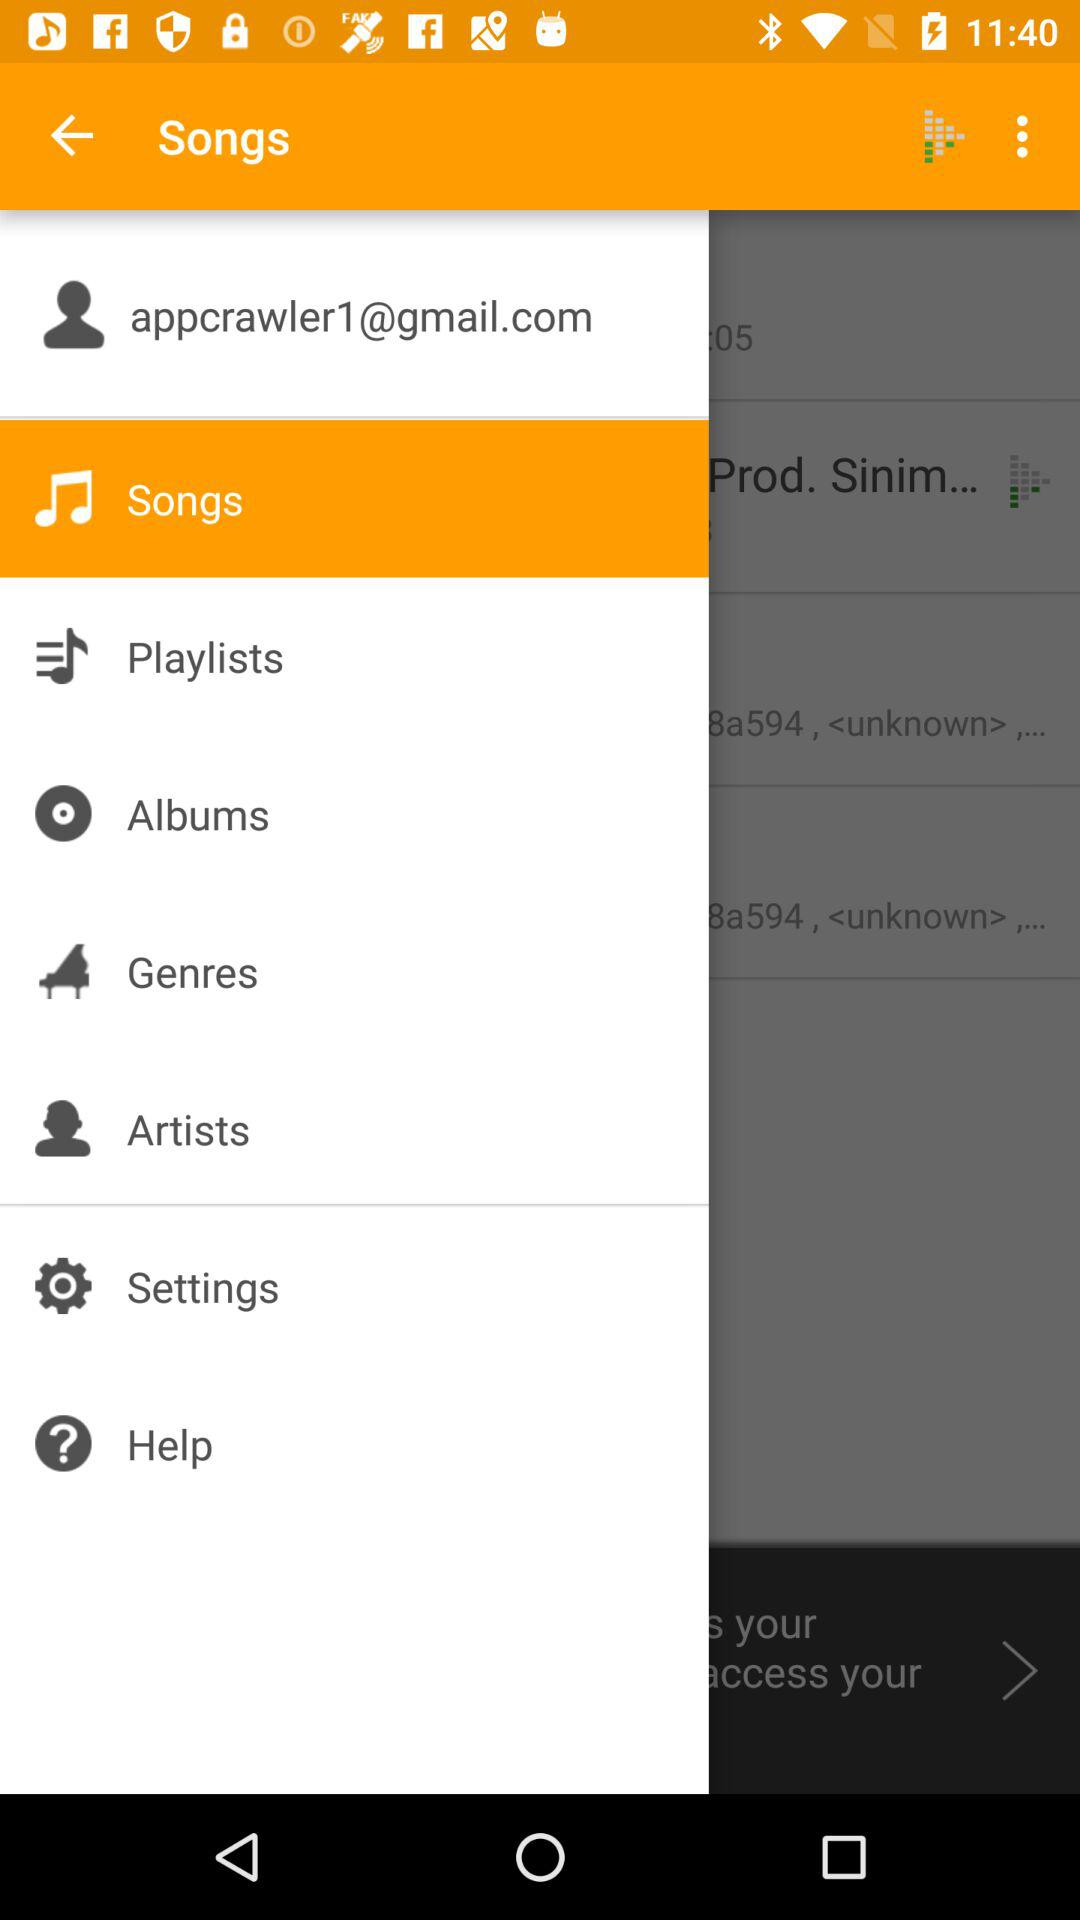Which item is selected? The selected item is "Songs". 